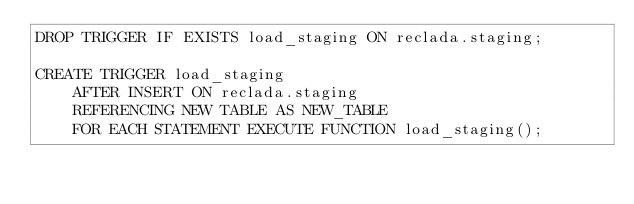<code> <loc_0><loc_0><loc_500><loc_500><_SQL_>DROP TRIGGER IF EXISTS load_staging ON reclada.staging;

CREATE TRIGGER load_staging
    AFTER INSERT ON reclada.staging
    REFERENCING NEW TABLE AS NEW_TABLE
    FOR EACH STATEMENT EXECUTE FUNCTION load_staging();
</code> 